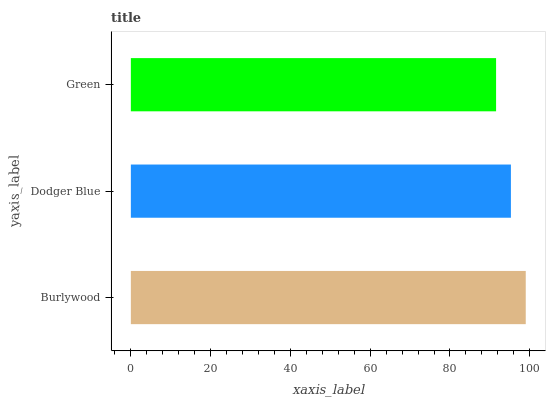Is Green the minimum?
Answer yes or no. Yes. Is Burlywood the maximum?
Answer yes or no. Yes. Is Dodger Blue the minimum?
Answer yes or no. No. Is Dodger Blue the maximum?
Answer yes or no. No. Is Burlywood greater than Dodger Blue?
Answer yes or no. Yes. Is Dodger Blue less than Burlywood?
Answer yes or no. Yes. Is Dodger Blue greater than Burlywood?
Answer yes or no. No. Is Burlywood less than Dodger Blue?
Answer yes or no. No. Is Dodger Blue the high median?
Answer yes or no. Yes. Is Dodger Blue the low median?
Answer yes or no. Yes. Is Burlywood the high median?
Answer yes or no. No. Is Burlywood the low median?
Answer yes or no. No. 